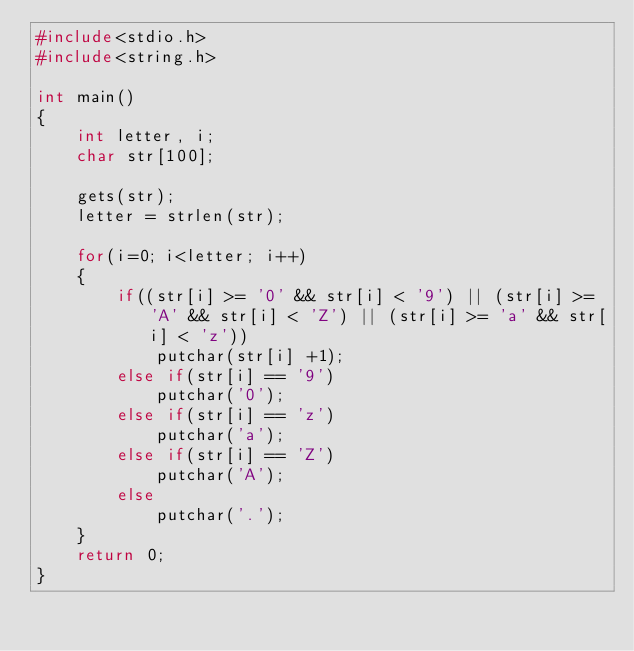<code> <loc_0><loc_0><loc_500><loc_500><_C_>#include<stdio.h>
#include<string.h>

int main()
{
    int letter, i;
    char str[100];

    gets(str);
    letter = strlen(str);

    for(i=0; i<letter; i++)
    {
        if((str[i] >= '0' && str[i] < '9') || (str[i] >= 'A' && str[i] < 'Z') || (str[i] >= 'a' && str[i] < 'z'))
            putchar(str[i] +1);
        else if(str[i] == '9')
            putchar('0');
        else if(str[i] == 'z')
            putchar('a');
        else if(str[i] == 'Z')
            putchar('A');
        else
            putchar('.');
    }
    return 0;
}
</code> 